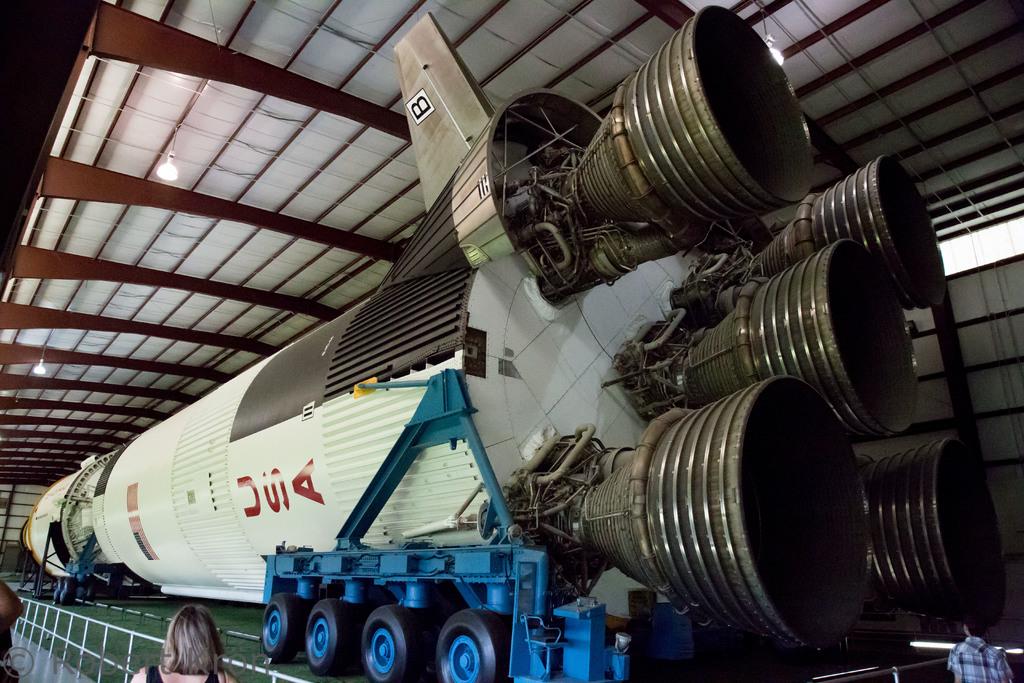What letter is on the wing?
Give a very brief answer. Usa. What country is mentioned on the rocket?
Offer a very short reply. Usa. 